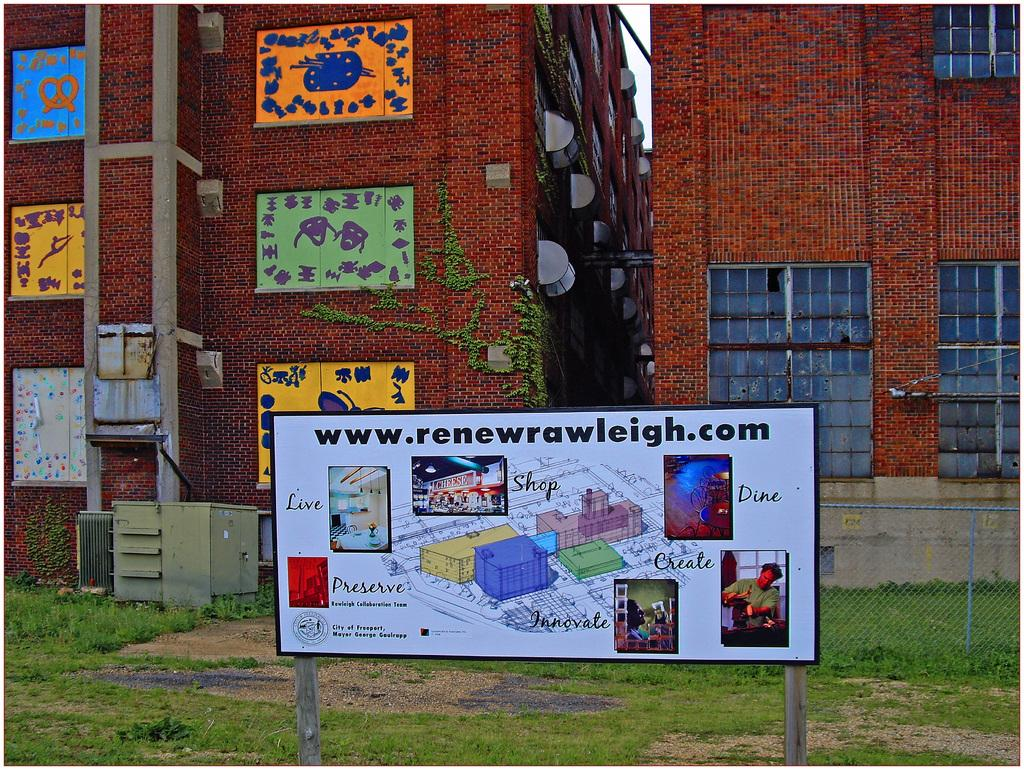<image>
Give a short and clear explanation of the subsequent image. A sign in front of two buildings has the URL www.renewrawleigh.com printed on it. 